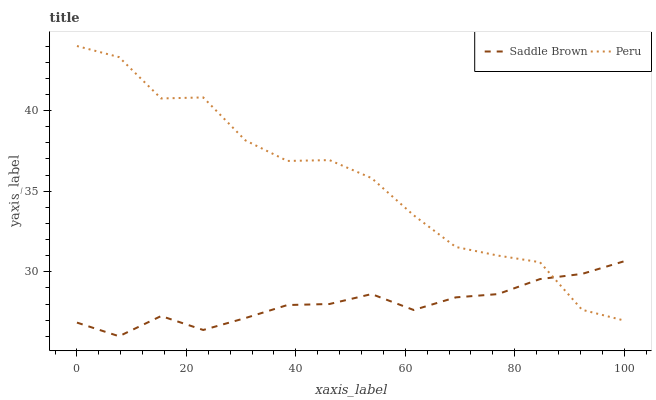Does Saddle Brown have the minimum area under the curve?
Answer yes or no. Yes. Does Peru have the maximum area under the curve?
Answer yes or no. Yes. Does Peru have the minimum area under the curve?
Answer yes or no. No. Is Saddle Brown the smoothest?
Answer yes or no. Yes. Is Peru the roughest?
Answer yes or no. Yes. Is Peru the smoothest?
Answer yes or no. No. Does Saddle Brown have the lowest value?
Answer yes or no. Yes. Does Peru have the lowest value?
Answer yes or no. No. Does Peru have the highest value?
Answer yes or no. Yes. Does Peru intersect Saddle Brown?
Answer yes or no. Yes. Is Peru less than Saddle Brown?
Answer yes or no. No. Is Peru greater than Saddle Brown?
Answer yes or no. No. 